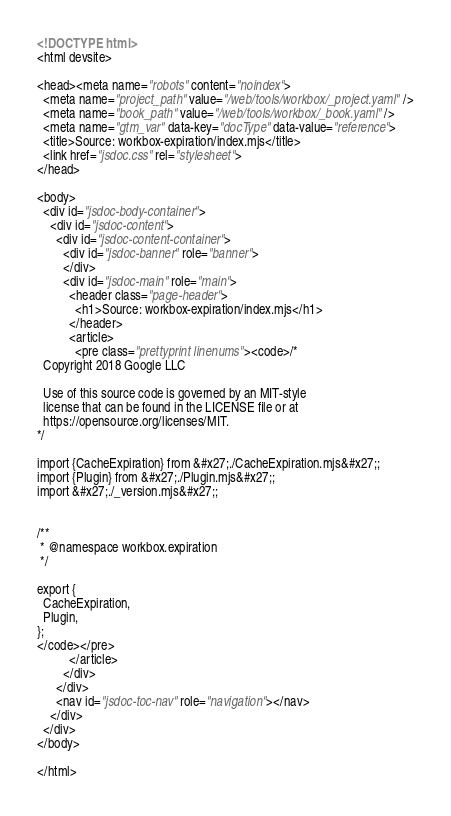Convert code to text. <code><loc_0><loc_0><loc_500><loc_500><_HTML_><!DOCTYPE html>
<html devsite>

<head><meta name="robots" content="noindex">
  <meta name="project_path" value="/web/tools/workbox/_project.yaml" />
  <meta name="book_path" value="/web/tools/workbox/_book.yaml" />
  <meta name="gtm_var" data-key="docType" data-value="reference">
  <title>Source: workbox-expiration/index.mjs</title>
  <link href="jsdoc.css" rel="stylesheet">
</head>

<body>
  <div id="jsdoc-body-container">
    <div id="jsdoc-content">
      <div id="jsdoc-content-container">
        <div id="jsdoc-banner" role="banner">
        </div>
        <div id="jsdoc-main" role="main">
          <header class="page-header">
            <h1>Source: workbox-expiration/index.mjs</h1>
          </header>
          <article>
            <pre class="prettyprint linenums"><code>/*
  Copyright 2018 Google LLC

  Use of this source code is governed by an MIT-style
  license that can be found in the LICENSE file or at
  https://opensource.org/licenses/MIT.
*/

import {CacheExpiration} from &#x27;./CacheExpiration.mjs&#x27;;
import {Plugin} from &#x27;./Plugin.mjs&#x27;;
import &#x27;./_version.mjs&#x27;;


/**
 * @namespace workbox.expiration
 */

export {
  CacheExpiration,
  Plugin,
};
</code></pre>
          </article>
        </div>
      </div>
      <nav id="jsdoc-toc-nav" role="navigation"></nav>
    </div>
  </div>
</body>

</html></code> 